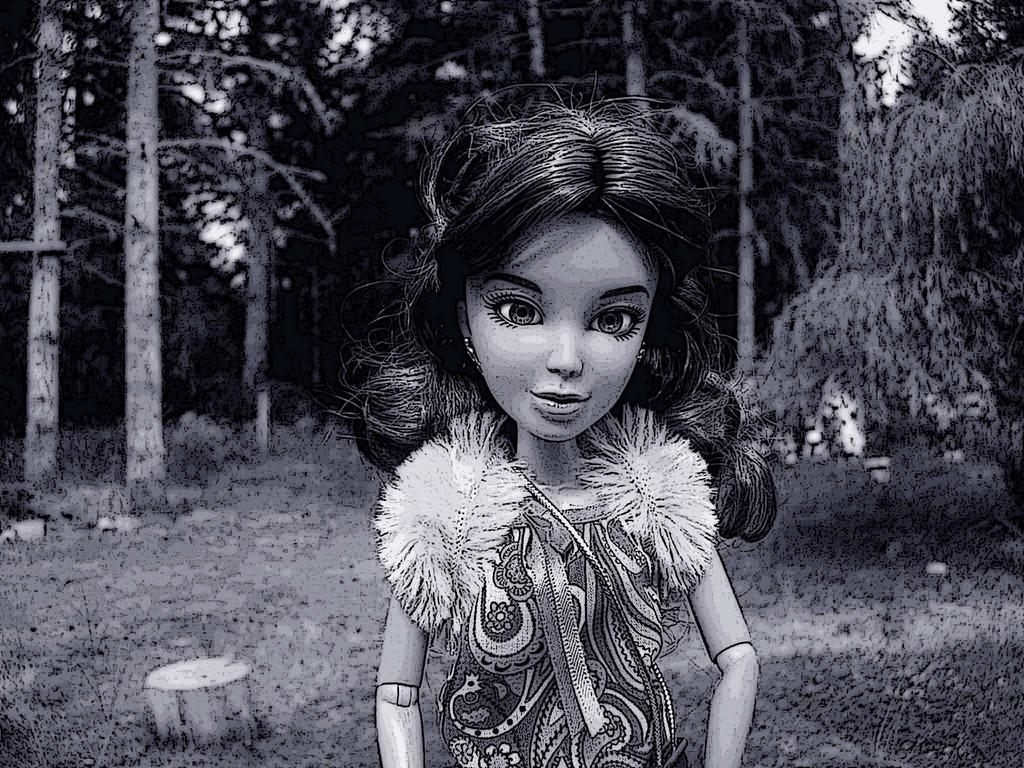What is the color scheme of the image? The image is black and white. What is the main subject in the middle of the image? There is a graphical image of a girl in the middle of the image. What can be seen in the background of the image? There are tall trees in the background of the image. What type of vegetation is on the ground in the image? There is grass on the ground in the image. How many frames are visible in the image? There are no frames present in the image; it is a black and white image with a graphical image of a girl, tall trees in the background, and grass on the ground. Can you spot any ladybugs in the image? There are no ladybugs present in the image. 